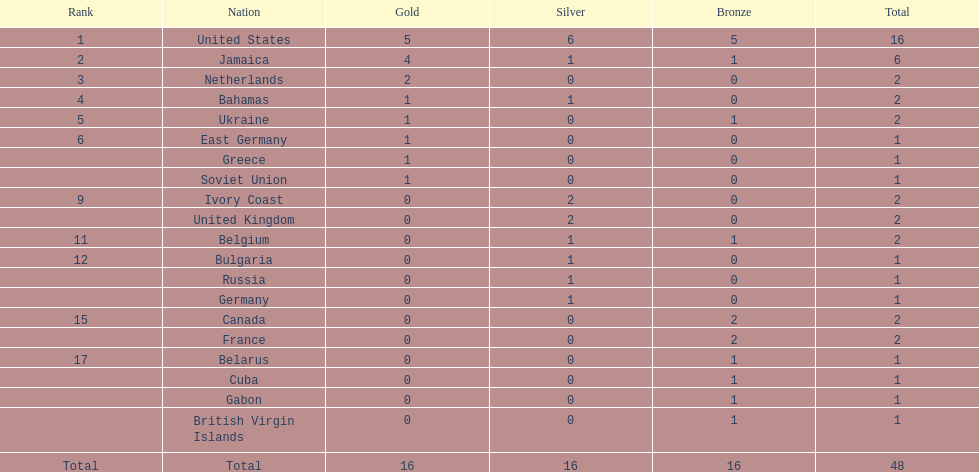I'm looking to parse the entire table for insights. Could you assist me with that? {'header': ['Rank', 'Nation', 'Gold', 'Silver', 'Bronze', 'Total'], 'rows': [['1', 'United States', '5', '6', '5', '16'], ['2', 'Jamaica', '4', '1', '1', '6'], ['3', 'Netherlands', '2', '0', '0', '2'], ['4', 'Bahamas', '1', '1', '0', '2'], ['5', 'Ukraine', '1', '0', '1', '2'], ['6', 'East Germany', '1', '0', '0', '1'], ['', 'Greece', '1', '0', '0', '1'], ['', 'Soviet Union', '1', '0', '0', '1'], ['9', 'Ivory Coast', '0', '2', '0', '2'], ['', 'United Kingdom', '0', '2', '0', '2'], ['11', 'Belgium', '0', '1', '1', '2'], ['12', 'Bulgaria', '0', '1', '0', '1'], ['', 'Russia', '0', '1', '0', '1'], ['', 'Germany', '0', '1', '0', '1'], ['15', 'Canada', '0', '0', '2', '2'], ['', 'France', '0', '0', '2', '2'], ['17', 'Belarus', '0', '0', '1', '1'], ['', 'Cuba', '0', '0', '1', '1'], ['', 'Gabon', '0', '0', '1', '1'], ['', 'British Virgin Islands', '0', '0', '1', '1'], ['Total', 'Total', '16', '16', '16', '48']]} What is the mean count of gold medals obtained by the leading five countries? 2.6. 